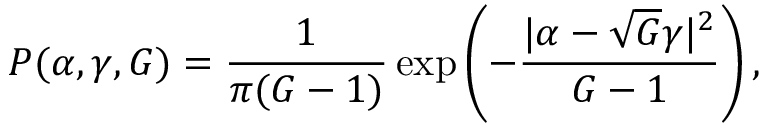<formula> <loc_0><loc_0><loc_500><loc_500>P ( \alpha , \gamma , G ) = \frac { 1 } { \pi ( G - 1 ) } \exp \left ( - \frac { | \alpha - \sqrt { G } \gamma | ^ { 2 } } { G - 1 } \right ) ,</formula> 